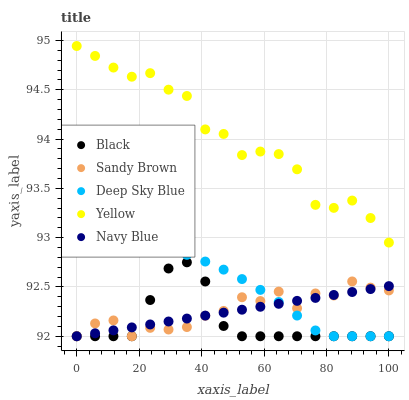Does Black have the minimum area under the curve?
Answer yes or no. Yes. Does Yellow have the maximum area under the curve?
Answer yes or no. Yes. Does Yellow have the minimum area under the curve?
Answer yes or no. No. Does Black have the maximum area under the curve?
Answer yes or no. No. Is Navy Blue the smoothest?
Answer yes or no. Yes. Is Yellow the roughest?
Answer yes or no. Yes. Is Black the smoothest?
Answer yes or no. No. Is Black the roughest?
Answer yes or no. No. Does Sandy Brown have the lowest value?
Answer yes or no. Yes. Does Yellow have the lowest value?
Answer yes or no. No. Does Yellow have the highest value?
Answer yes or no. Yes. Does Black have the highest value?
Answer yes or no. No. Is Deep Sky Blue less than Yellow?
Answer yes or no. Yes. Is Yellow greater than Black?
Answer yes or no. Yes. Does Sandy Brown intersect Navy Blue?
Answer yes or no. Yes. Is Sandy Brown less than Navy Blue?
Answer yes or no. No. Is Sandy Brown greater than Navy Blue?
Answer yes or no. No. Does Deep Sky Blue intersect Yellow?
Answer yes or no. No. 